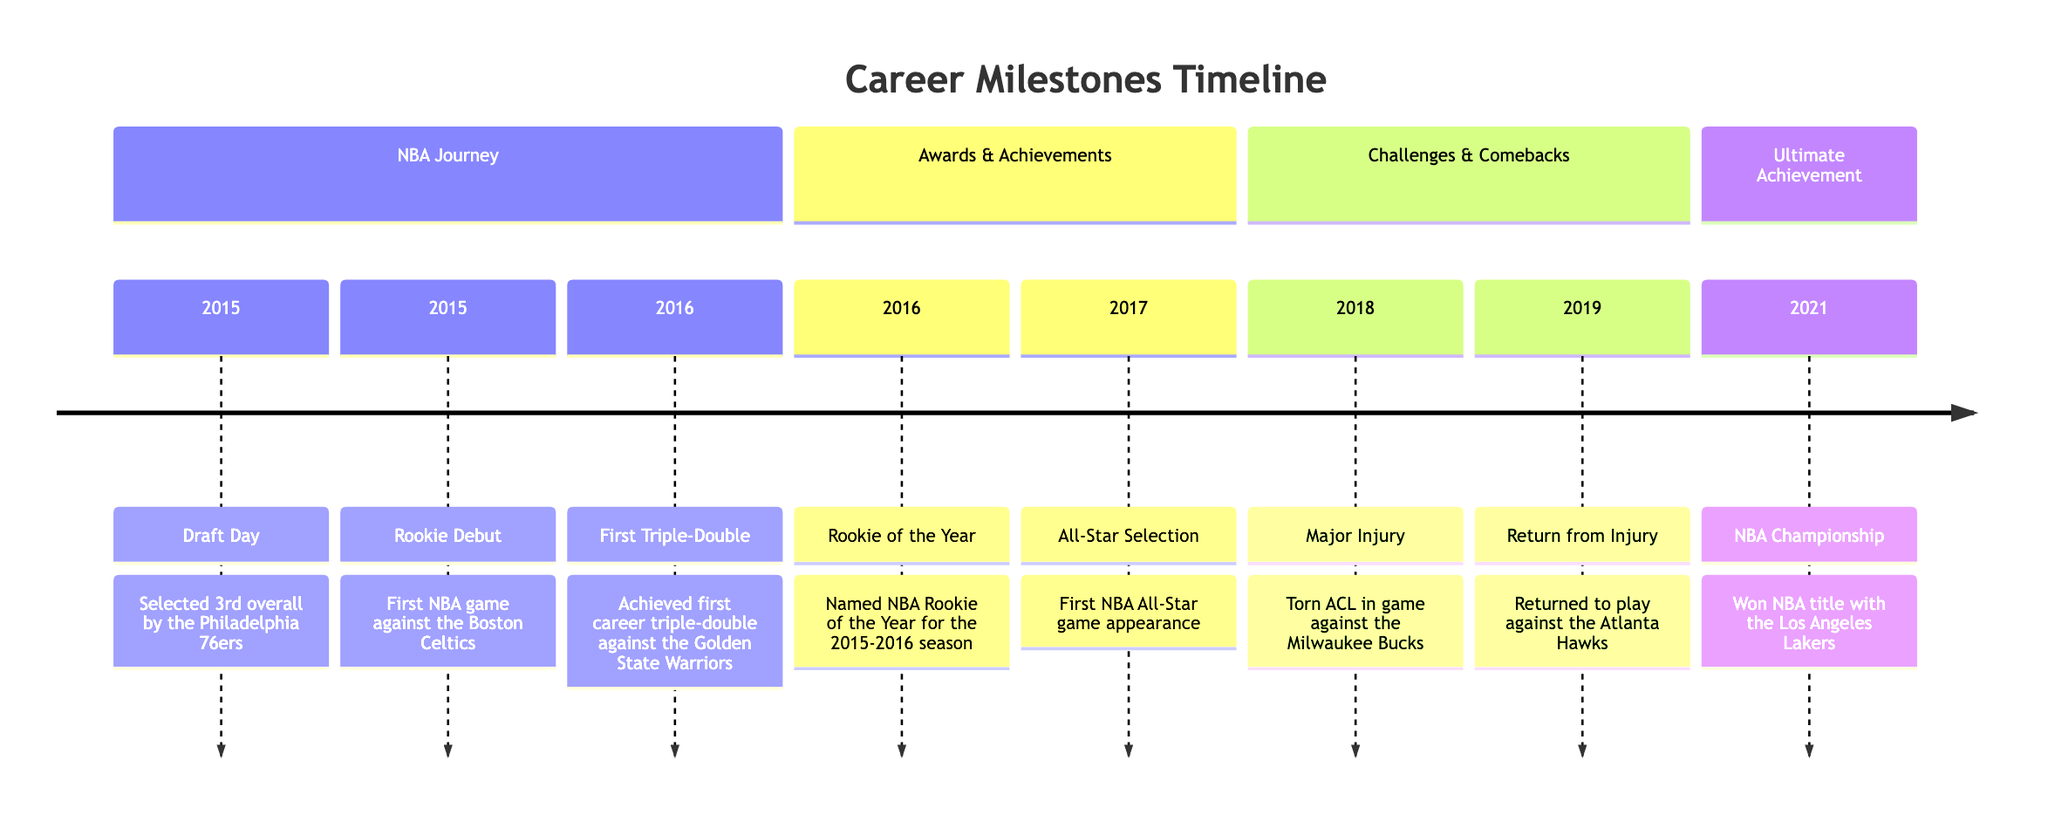What year was the NBA Championship won? The timeline section "Ultimate Achievement" shows that the NBA Championship was won in 2021.
Answer: 2021 What team was selected on Draft Day? The timeline section "NBA Journey" notes that the player was selected by the Philadelphia 76ers on Draft Day.
Answer: Philadelphia 76ers How many All-Star selections are listed in the diagram? The timeline section "Awards & Achievements" indicates there is only one All-Star Selection listed for the year 2017.
Answer: 1 What significant event occurred in 2018? The timeline section "Challenges & Comebacks" states that a major injury (torn ACL) occurred in 2018.
Answer: Major Injury When did the player's first triple-double occur? In the "NBA Journey" section, the timeline specifies that the first triple-double was achieved in 2016 against the Golden State Warriors.
Answer: 2016 What major injury is mentioned in the timeline? The timeline details that the major injury was a torn ACL, specifically mentioned in the section "Challenges & Comebacks."
Answer: Torn ACL What is the significance of the year 2016 in the diagram? The year 2016 is significant because it includes multiple key milestones, such as the Rookie of the Year award and the first triple-double.
Answer: Rookie of the Year, First Triple-Double In which section is the "Return from Injury" mentioned? The "Return from Injury" event is noted in the section "Challenges & Comebacks" of the timeline.
Answer: Challenges & Comebacks What was achieved on Draft Day? The timeline reveals that on Draft Day, the player was selected 3rd overall.
Answer: Selected 3rd overall 